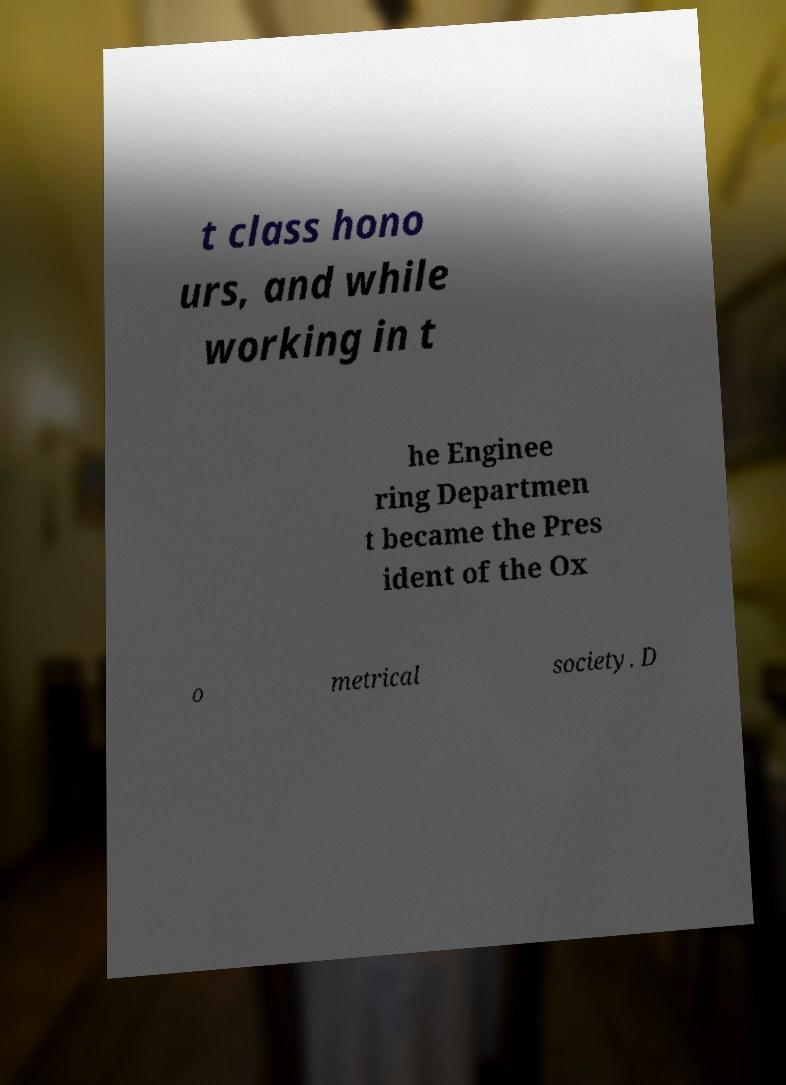Could you extract and type out the text from this image? t class hono urs, and while working in t he Enginee ring Departmen t became the Pres ident of the Ox o metrical society. D 